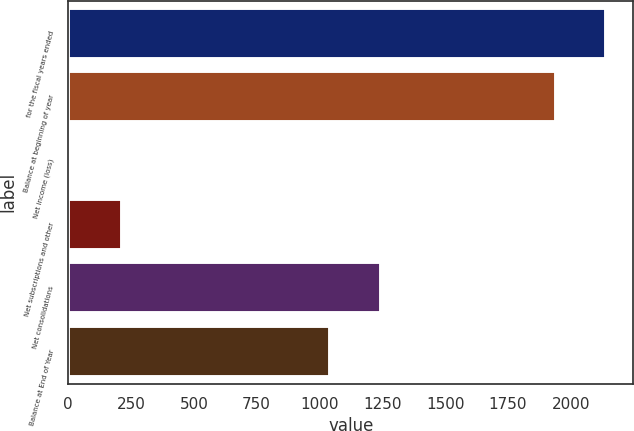Convert chart. <chart><loc_0><loc_0><loc_500><loc_500><bar_chart><fcel>for the fiscal years ended<fcel>Balance at beginning of year<fcel>Net income (loss)<fcel>Net subscriptions and other<fcel>Net consolidations<fcel>Balance at End of Year<nl><fcel>2142.42<fcel>1941.9<fcel>12.8<fcel>213.32<fcel>1244.12<fcel>1043.6<nl></chart> 